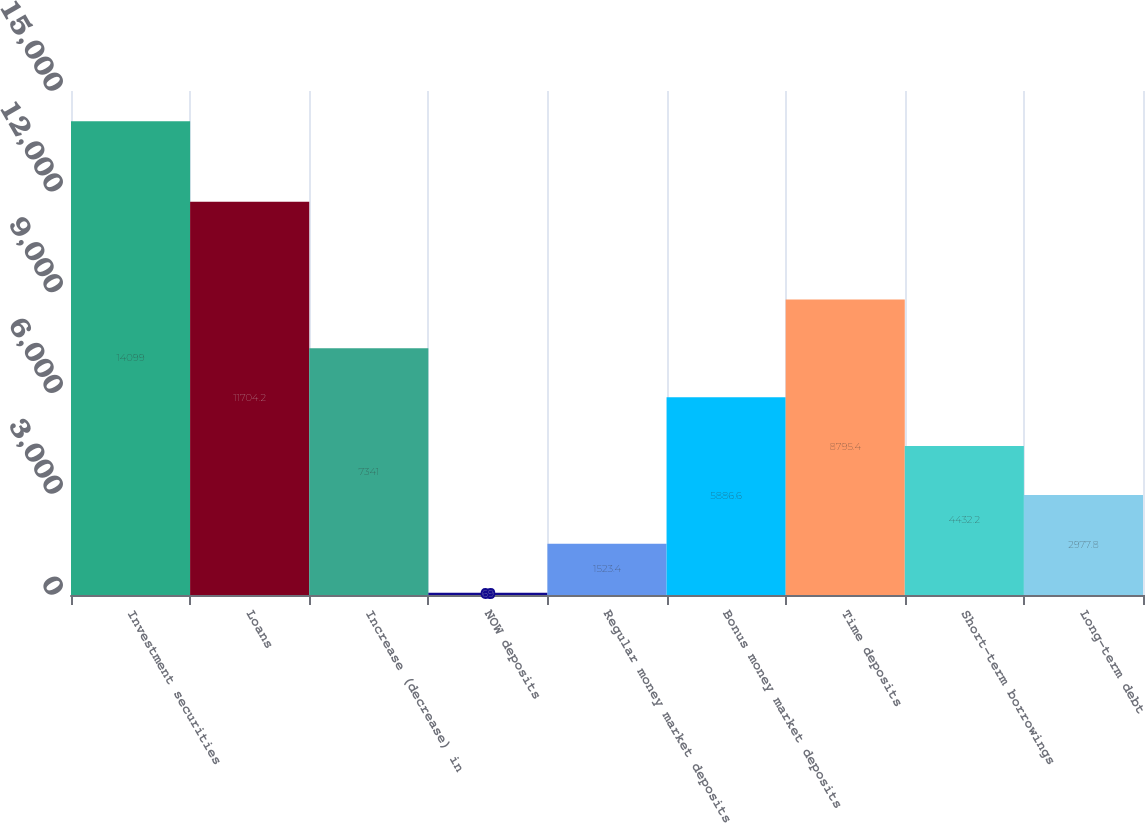<chart> <loc_0><loc_0><loc_500><loc_500><bar_chart><fcel>Investment securities<fcel>Loans<fcel>Increase (decrease) in<fcel>NOW deposits<fcel>Regular money market deposits<fcel>Bonus money market deposits<fcel>Time deposits<fcel>Short-term borrowings<fcel>Long-term debt<nl><fcel>14099<fcel>11704.2<fcel>7341<fcel>69<fcel>1523.4<fcel>5886.6<fcel>8795.4<fcel>4432.2<fcel>2977.8<nl></chart> 